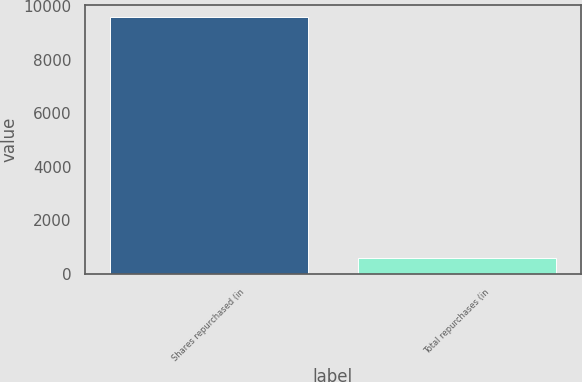<chart> <loc_0><loc_0><loc_500><loc_500><bar_chart><fcel>Shares repurchased (in<fcel>Total repurchases (in<nl><fcel>9569<fcel>600<nl></chart> 